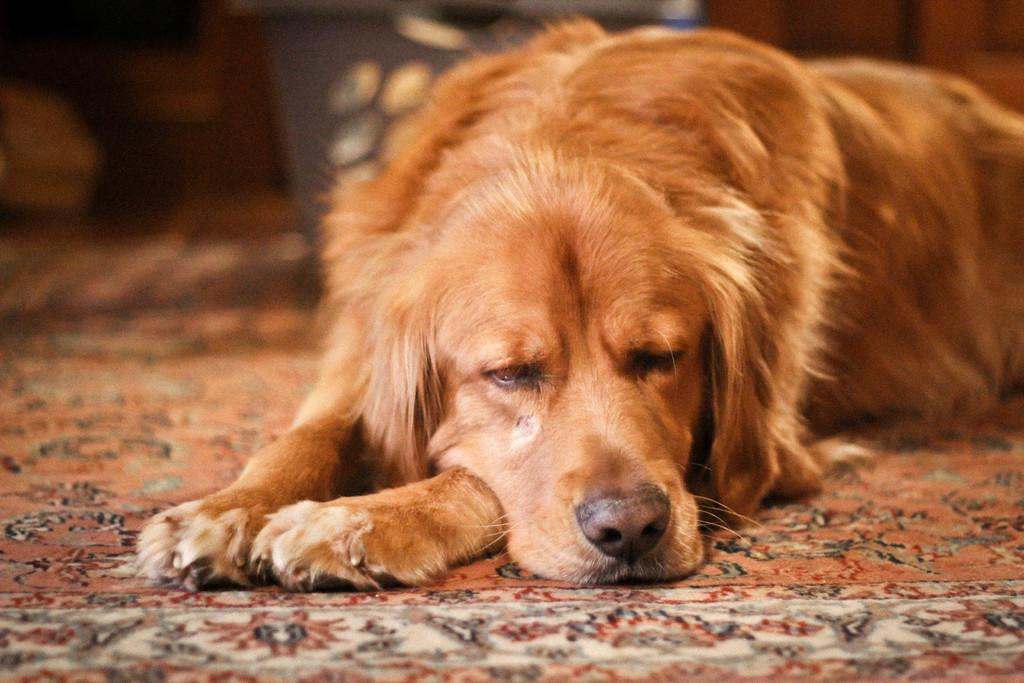What type of animal is in the image? There is a dog in the image. What can be seen beneath the dog? The ground is visible in the image. Can you describe the background of the image? The background of the image is blurred. Is the dog stuck in quicksand in the image? No, there is no quicksand present in the image. The dog is standing on the visible ground. 